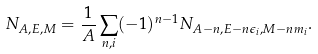Convert formula to latex. <formula><loc_0><loc_0><loc_500><loc_500>N _ { A , E , M } = \frac { 1 } { A } \sum _ { n , i } ( - 1 ) ^ { n - 1 } N _ { A - n , E - n \epsilon _ { i } , M - n m _ { i } } .</formula> 